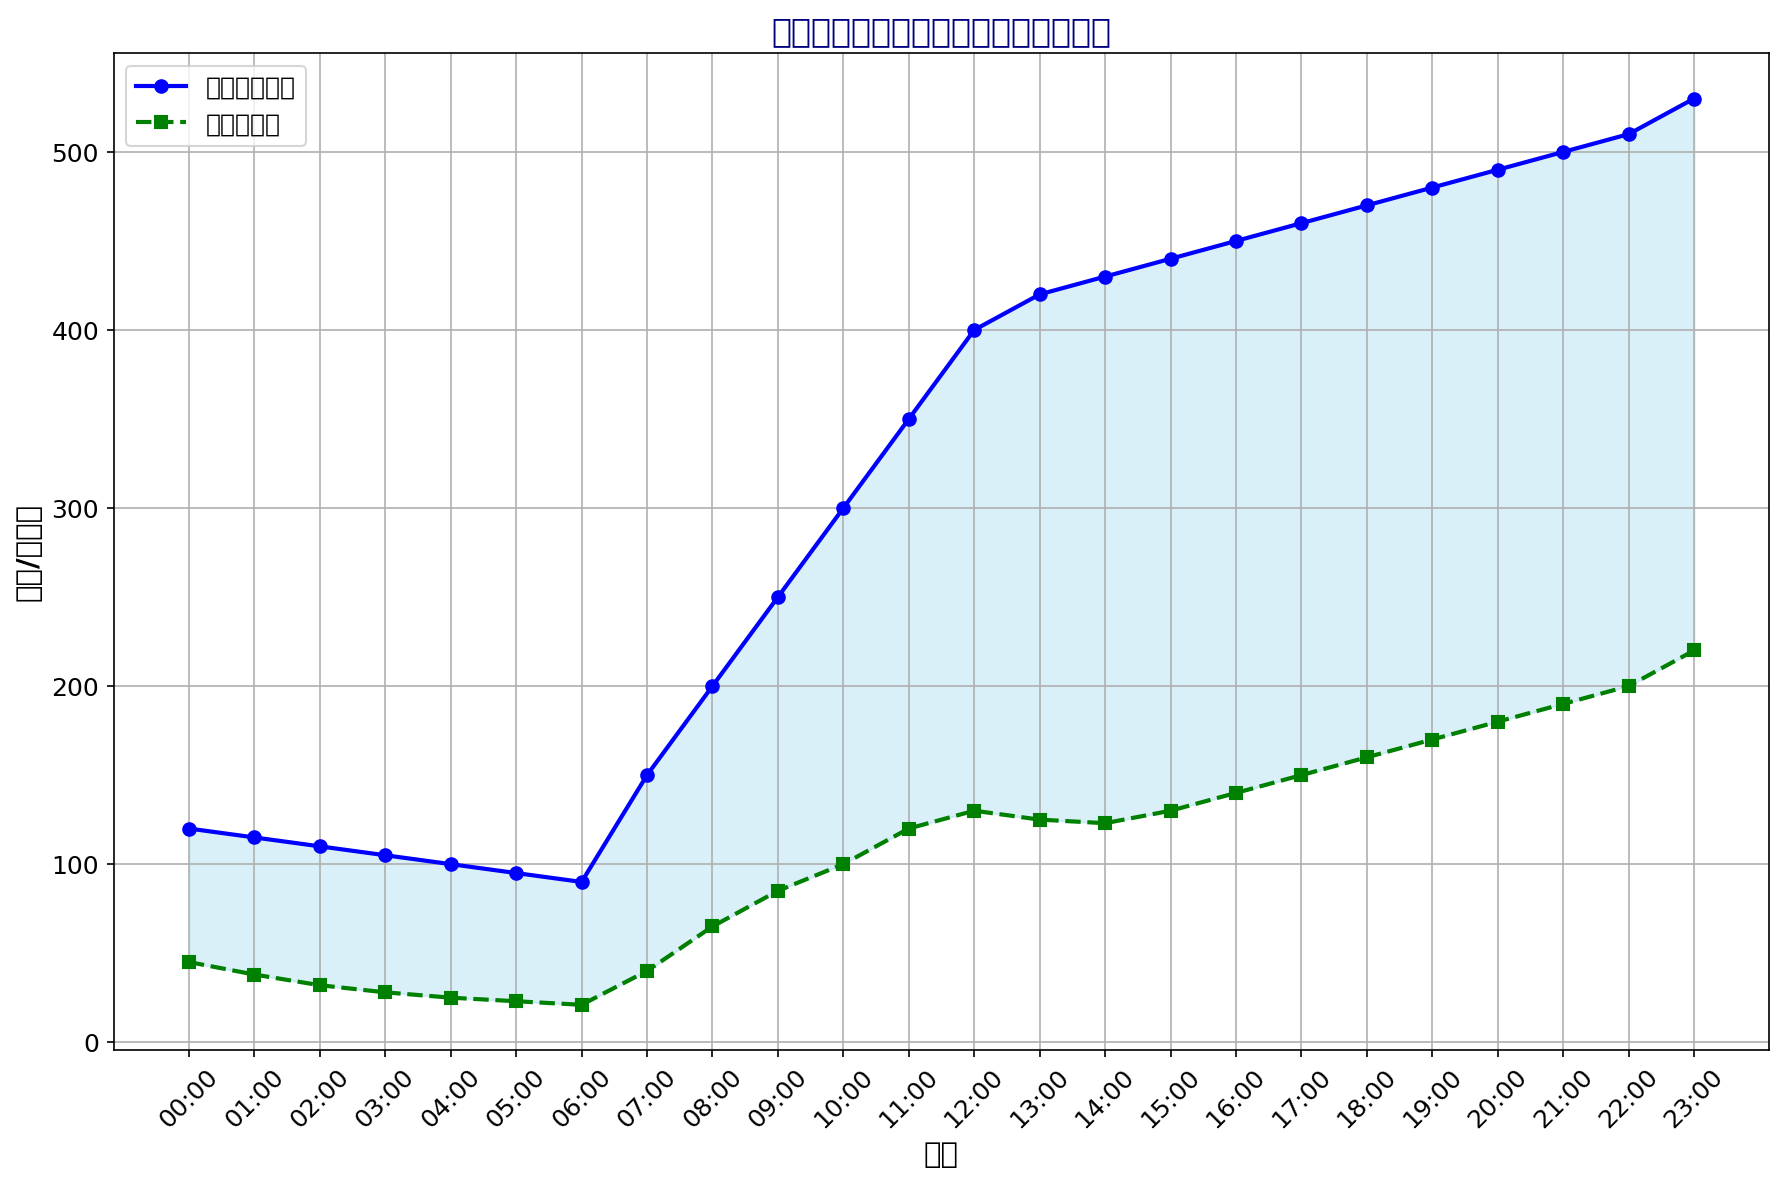任务完成数量和商城点击率在什么时候达到最高？ 首先，通过观察横坐标为时间的图表，我们可以看到任务完成数量的最高点和商城点击率的最高点。如果从图中可以看到在23:00时，任务完成数量为530，而商城点击率达到220，都是全天最高。
Answer: 23:00 任务完成数量和商城点击率的最低点之间的差异是多少？ 最少的任务完成数量是06:00时的90。而商城点击率的最低点是05:00时的23。因此差异为90-23。
Answer: 67 从08:00到18:00之间，任务完成数量和商城点击率的平均值分别是多少？ 任务完成数量在08:00到18:00数据有：200, 250, 300, 350, 400, 420, 430, 440, 450, 460, 470。将这些数据相加得到4170，除以11得到平均值 4170/11 = 379.09。 商城点击率在08:00到18:00数据有：65, 85, 100, 120, 130, 125, 123, 130, 140, 150, 160。将这些数据相加得到1230，除以11得到平均值1230/11 = 111.82。
Answer: 379.09和111.82 从图中可以看出，任务完成数量和商城点击率在哪个时间段上升最快？ 任务完成数量和商城点击率在09:00到11:00的时间段的上升最陡峭。11:00任务完成数量达到了350，而09:00任务完成数量为250，显然在这期间增加了100。而商城点击率在11:00达到了120，09:00时则是85，增加了35。
Answer: 09:00到11:00 哪两个时间段之间，任务完成数量下降最多？ 任务完成数量下降最多的是从07:00到01:00，因为07:00时任务完成数量为150，而01:00时任务完成数量为115。因此该时间段下降了150 - 115 = 35。
Answer: 从07:00到01:00 